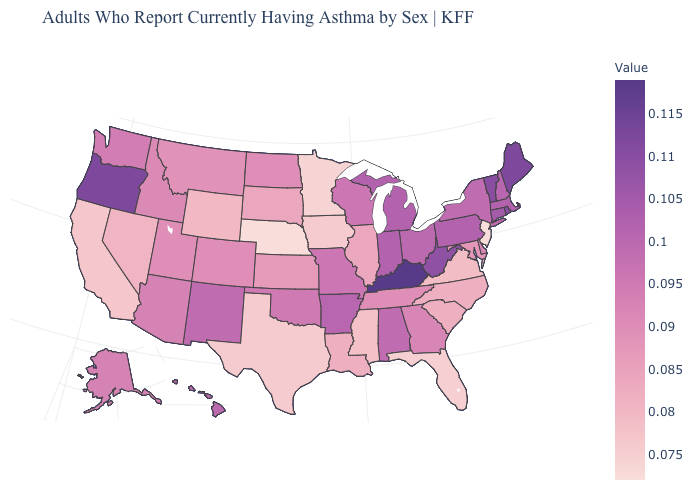Which states have the lowest value in the Northeast?
Write a very short answer. New Jersey. Does the map have missing data?
Concise answer only. No. Does Nebraska have the lowest value in the USA?
Answer briefly. Yes. 